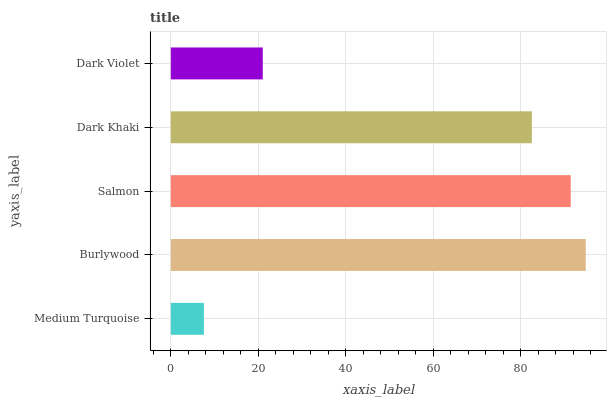Is Medium Turquoise the minimum?
Answer yes or no. Yes. Is Burlywood the maximum?
Answer yes or no. Yes. Is Salmon the minimum?
Answer yes or no. No. Is Salmon the maximum?
Answer yes or no. No. Is Burlywood greater than Salmon?
Answer yes or no. Yes. Is Salmon less than Burlywood?
Answer yes or no. Yes. Is Salmon greater than Burlywood?
Answer yes or no. No. Is Burlywood less than Salmon?
Answer yes or no. No. Is Dark Khaki the high median?
Answer yes or no. Yes. Is Dark Khaki the low median?
Answer yes or no. Yes. Is Dark Violet the high median?
Answer yes or no. No. Is Burlywood the low median?
Answer yes or no. No. 